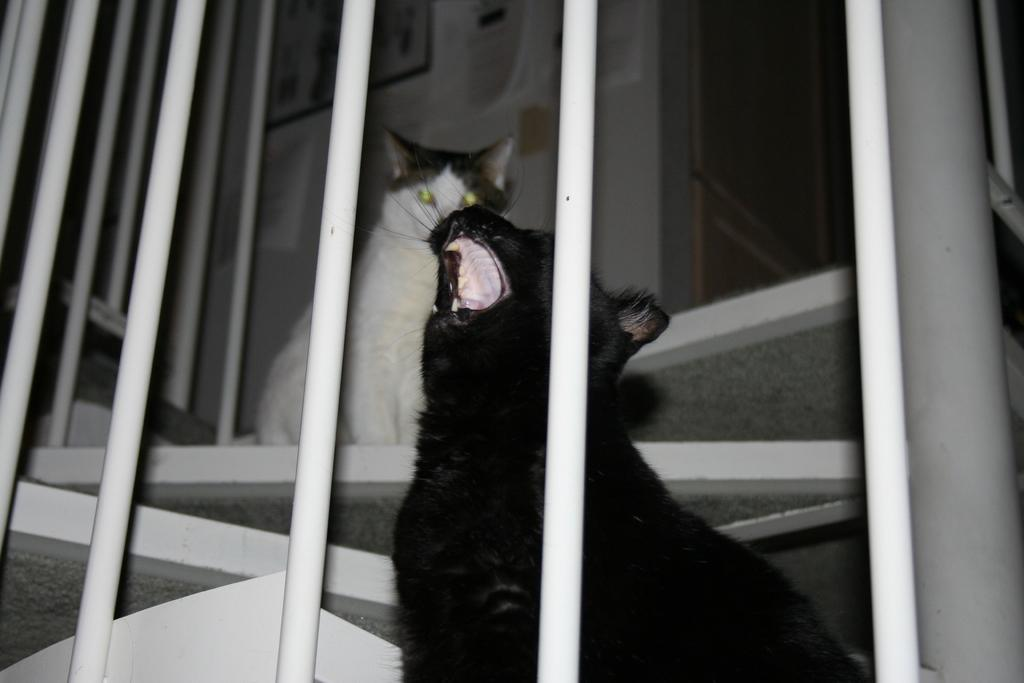What types of living organisms can be seen in the image? There are animals in the image. What architectural feature is present in the image? There are stairs in the image. What safety feature is included in the image? There is a railing in the image. What can be seen on the wall in the image? There is a wall with some objects in the image. What type of father can be seen in the image? There is no father present in the image; it features animals and various architectural and safety features. Can you spot a frog in the image? There is no frog present in the image. 